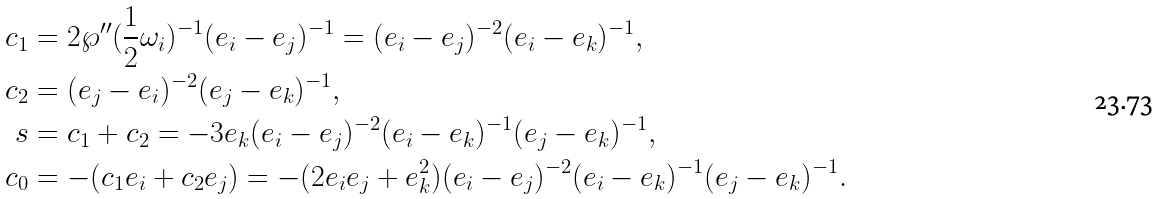Convert formula to latex. <formula><loc_0><loc_0><loc_500><loc_500>c _ { 1 } & = 2 \wp ^ { \prime \prime } ( \frac { 1 } { 2 } \omega _ { i } ) ^ { - 1 } ( e _ { i } - e _ { j } ) ^ { - 1 } = ( e _ { i } - e _ { j } ) ^ { - 2 } ( e _ { i } - e _ { k } ) ^ { - 1 } , \\ c _ { 2 } & = ( e _ { j } - e _ { i } ) ^ { - 2 } ( e _ { j } - e _ { k } ) ^ { - 1 } , \\ s & = c _ { 1 } + c _ { 2 } = - 3 e _ { k } ( e _ { i } - e _ { j } ) ^ { - 2 } ( e _ { i } - e _ { k } ) ^ { - 1 } ( e _ { j } - e _ { k } ) ^ { - 1 } , \\ c _ { 0 } & = - ( c _ { 1 } e _ { i } + c _ { 2 } e _ { j } ) = - ( 2 e _ { i } e _ { j } + e _ { k } ^ { 2 } ) ( e _ { i } - e _ { j } ) ^ { - 2 } ( e _ { i } - e _ { k } ) ^ { - 1 } ( e _ { j } - e _ { k } ) ^ { - 1 } .</formula> 